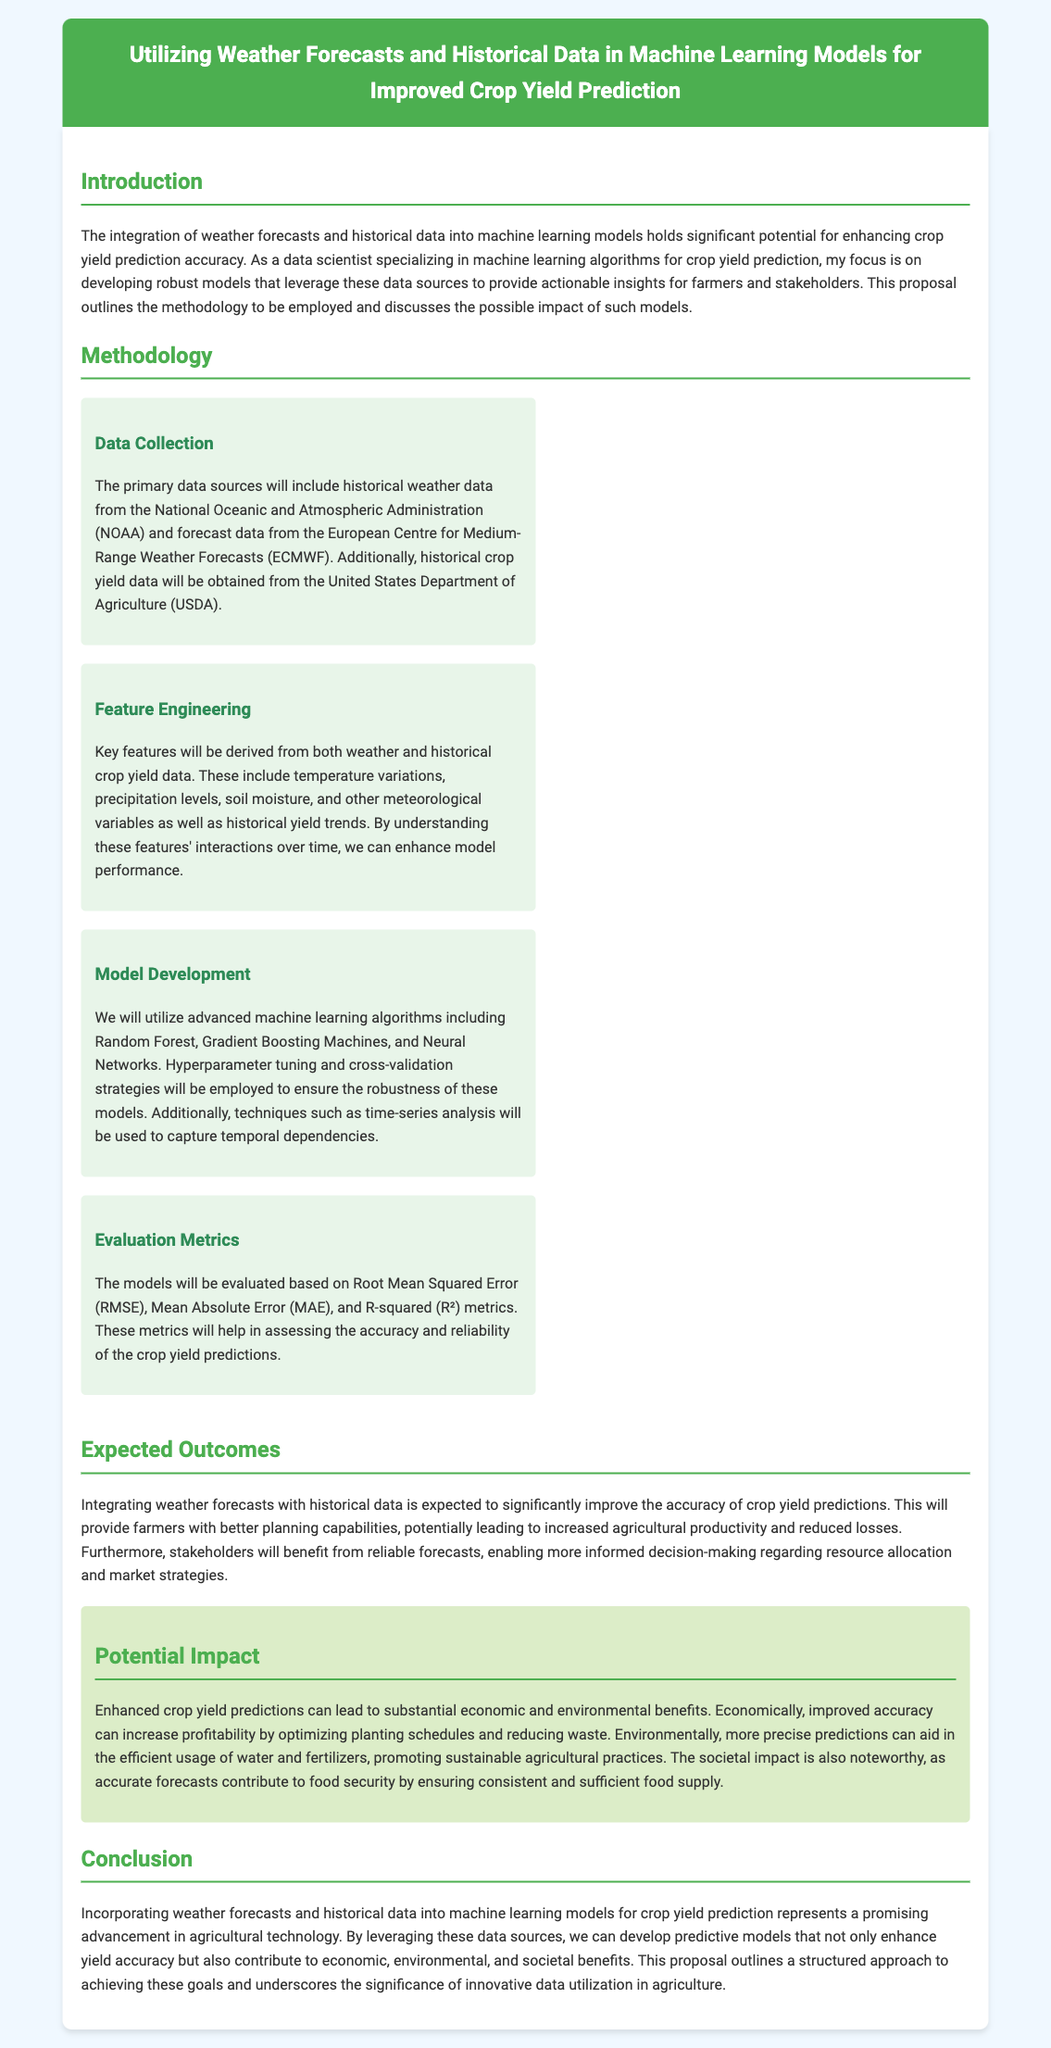What are the primary data sources for this study? The proposal mentions the primary data sources as historical weather data from the NOAA and forecast data from the ECMWF.
Answer: NOAA and ECMWF What machine learning algorithms will be utilized? The document lists Random Forest, Gradient Boosting Machines, and Neural Networks as the algorithms to be used.
Answer: Random Forest, Gradient Boosting Machines, Neural Networks What are the evaluation metrics specified? The metrics for evaluation include Root Mean Squared Error, Mean Absolute Error, and R-squared.
Answer: RMSE, MAE, R-squared What is the expected outcome of integrating weather forecasts with historical data? The integration is expected to significantly improve the accuracy of crop yield predictions.
Answer: Improved accuracy What is the societal impact mentioned in the proposal? The proposal states that accurate forecasts contribute to food security by ensuring consistent and sufficient food supply.
Answer: Food security Which department provides historical crop yield data? Historical crop yield data will be obtained from the United States Department of Agriculture.
Answer: United States Department of Agriculture What are the key features identified for the model? Key features include temperature variations, precipitation levels, soil moisture, and historical yield trends.
Answer: Temperature variations, precipitation levels, soil moisture, historical yield trends What does the proposal aim to optimize for farmers? The proposal aims to provide better planning capabilities for farmers.
Answer: Better planning capabilities 